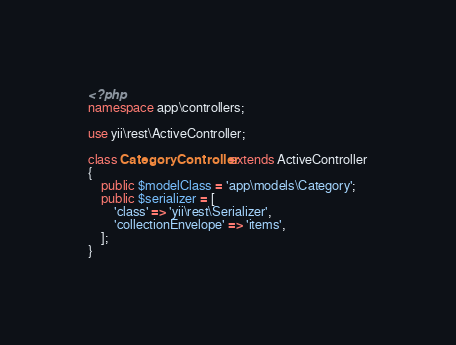Convert code to text. <code><loc_0><loc_0><loc_500><loc_500><_PHP_><?php
namespace app\controllers;

use yii\rest\ActiveController;

class CategoryController extends ActiveController
{
    public $modelClass = 'app\models\Category';
    public $serializer = [
        'class' => 'yii\rest\Serializer',
        'collectionEnvelope' => 'items',
    ];
}</code> 